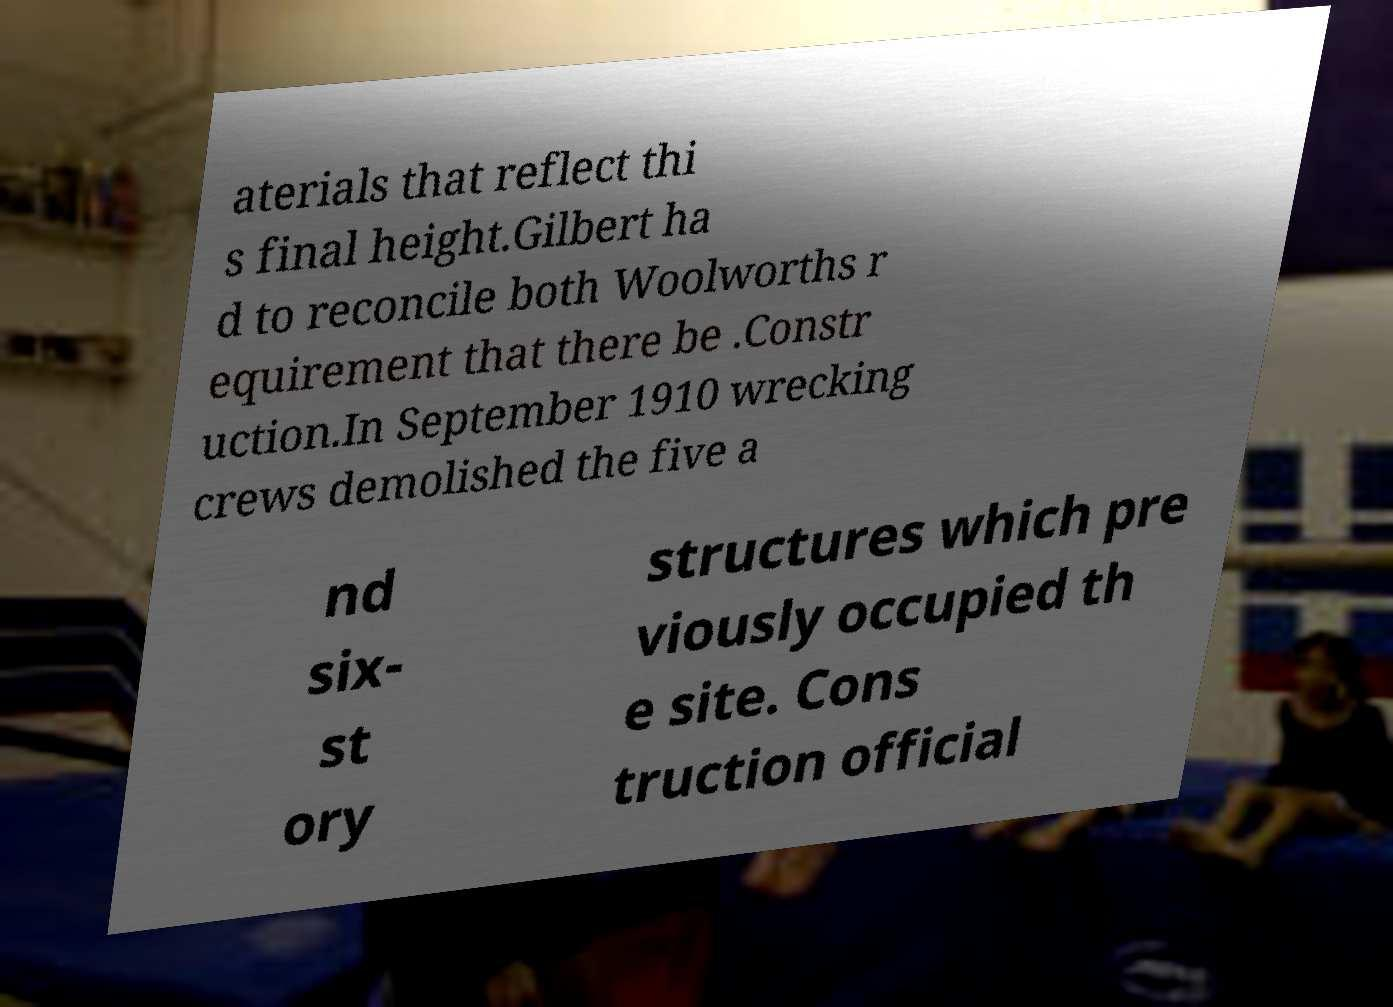What messages or text are displayed in this image? I need them in a readable, typed format. aterials that reflect thi s final height.Gilbert ha d to reconcile both Woolworths r equirement that there be .Constr uction.In September 1910 wrecking crews demolished the five a nd six- st ory structures which pre viously occupied th e site. Cons truction official 